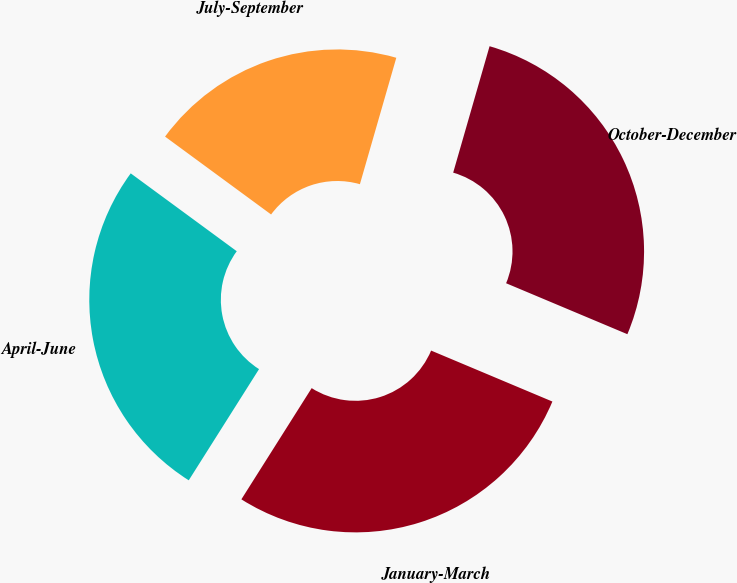<chart> <loc_0><loc_0><loc_500><loc_500><pie_chart><fcel>October-December<fcel>January-March<fcel>April-June<fcel>July-September<nl><fcel>26.87%<fcel>27.64%<fcel>26.11%<fcel>19.38%<nl></chart> 